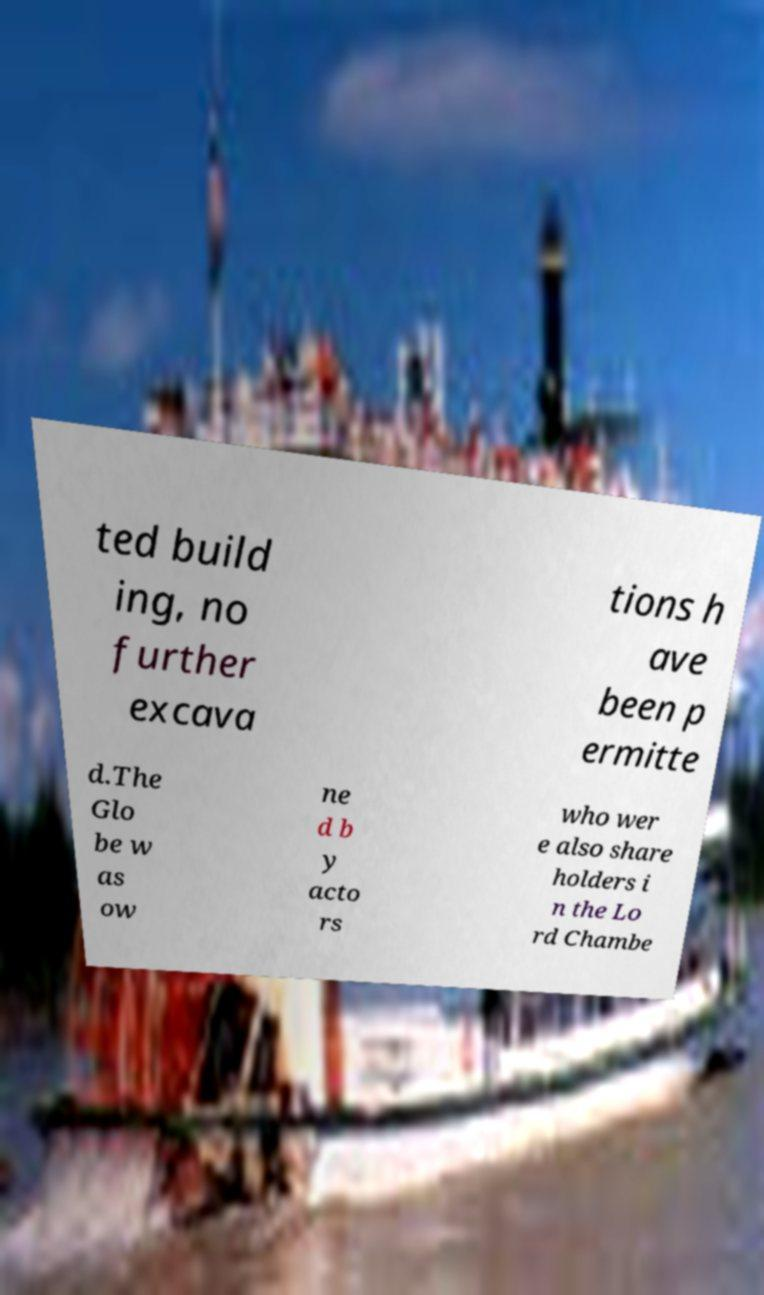I need the written content from this picture converted into text. Can you do that? ted build ing, no further excava tions h ave been p ermitte d.The Glo be w as ow ne d b y acto rs who wer e also share holders i n the Lo rd Chambe 